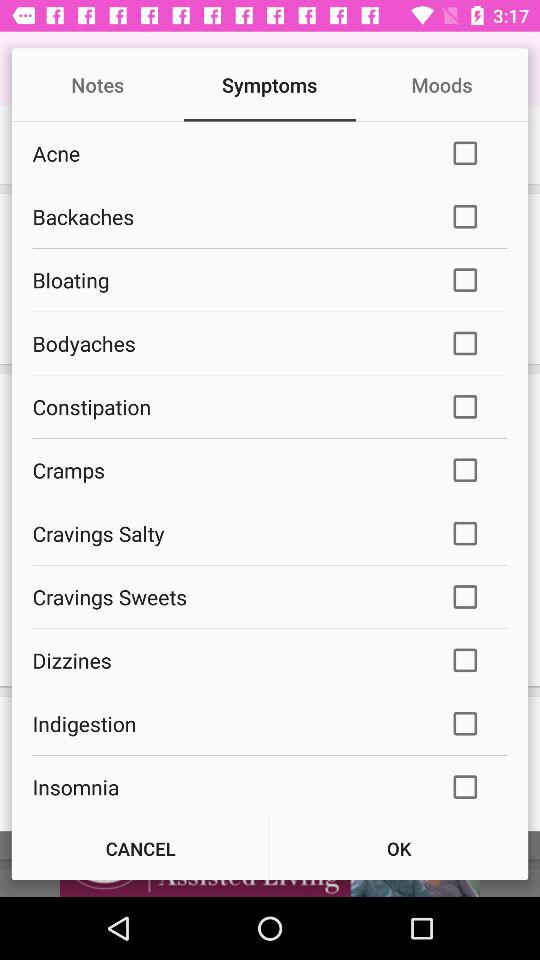What is the current status of "Cramps"? The current status is "off". 